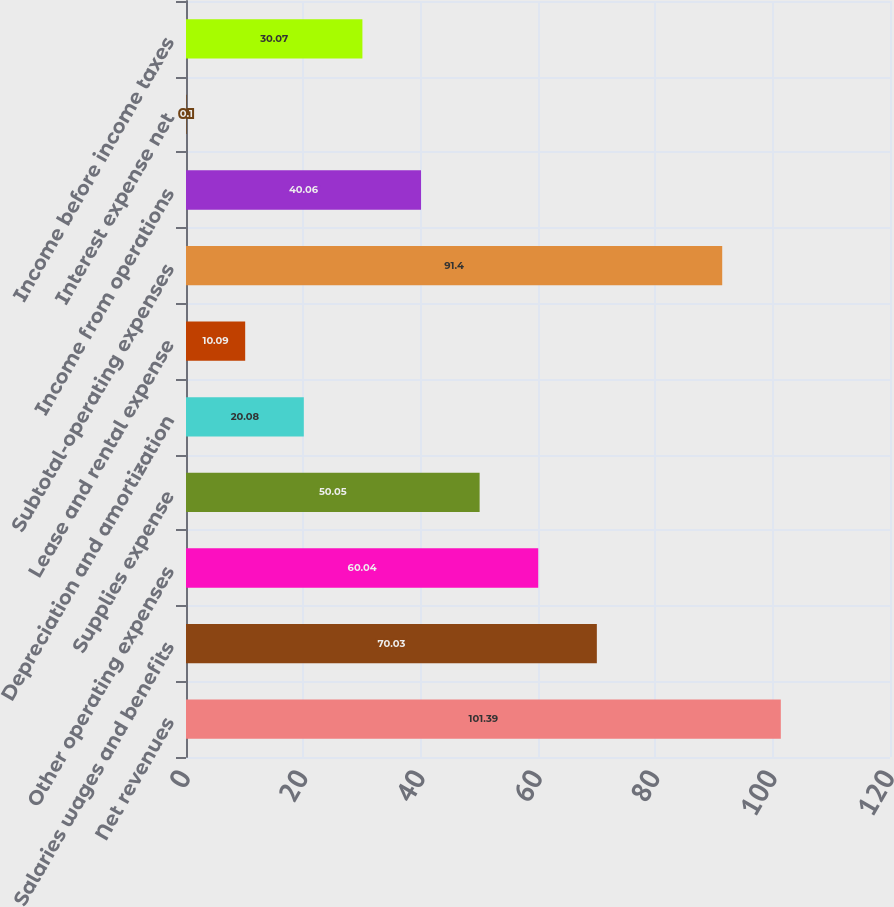Convert chart. <chart><loc_0><loc_0><loc_500><loc_500><bar_chart><fcel>Net revenues<fcel>Salaries wages and benefits<fcel>Other operating expenses<fcel>Supplies expense<fcel>Depreciation and amortization<fcel>Lease and rental expense<fcel>Subtotal-operating expenses<fcel>Income from operations<fcel>Interest expense net<fcel>Income before income taxes<nl><fcel>101.39<fcel>70.03<fcel>60.04<fcel>50.05<fcel>20.08<fcel>10.09<fcel>91.4<fcel>40.06<fcel>0.1<fcel>30.07<nl></chart> 